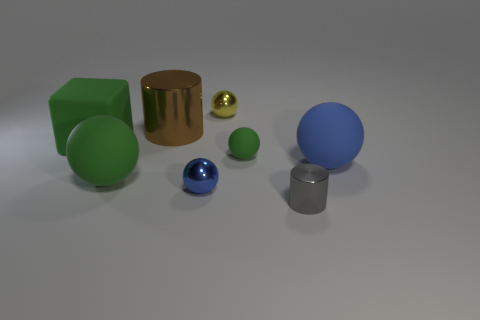Are there any tiny yellow spheres made of the same material as the yellow thing? No, there are not any tiny yellow spheres made of the same material as the large yellow cylinder. The only tiny sphere present in the image is a small golden sphere, which has a reflective surface distinct from the matte finish of the yellow object. 